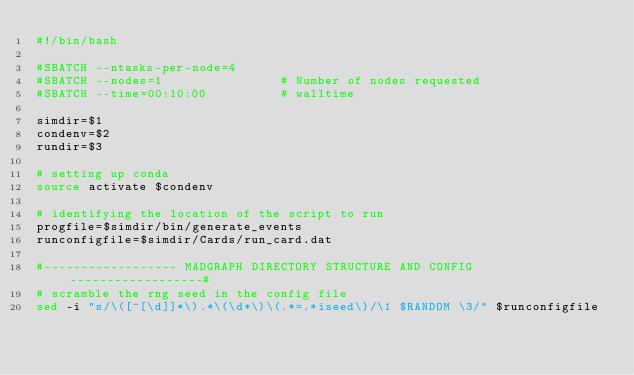Convert code to text. <code><loc_0><loc_0><loc_500><loc_500><_Bash_>#!/bin/bash

#SBATCH --ntasks-per-node=4
#SBATCH --nodes=1                # Number of nodes requested
#SBATCH --time=00:10:00          # walltime

simdir=$1
condenv=$2
rundir=$3

# setting up conda
source activate $condenv

# identifying the location of the script to run
progfile=$simdir/bin/generate_events
runconfigfile=$simdir/Cards/run_card.dat

#------------------ MADGRAPH DIRECTORY STRUCTURE AND CONFIG ------------------#
# scramble the rng seed in the config file
sed -i "s/\([^[\d]]*\).*\(\d*\)\(.*=.*iseed\)/\1 $RANDOM \3/" $runconfigfile

</code> 